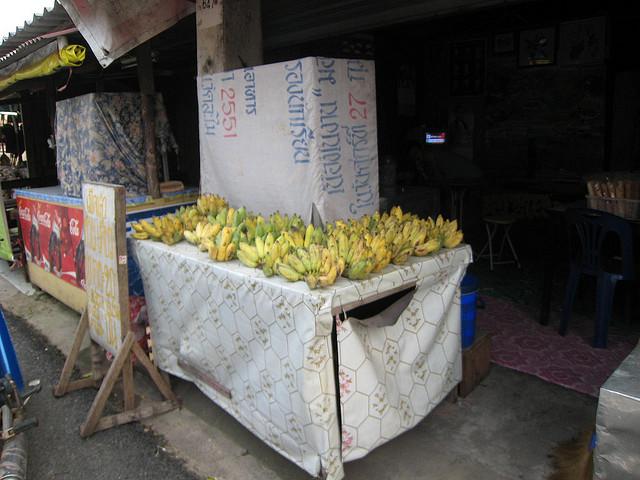What soda brand is being advertised?
Quick response, please. Coca-cola. Are the bananas ripe?
Be succinct. No. Where do all the fruits and vegetables come from?
Answer briefly. Trees. Are the bananas for sale?
Give a very brief answer. Yes. 